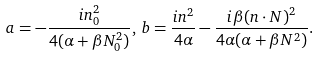<formula> <loc_0><loc_0><loc_500><loc_500>a = - \frac { i n _ { 0 } ^ { 2 } } { 4 ( \alpha + \beta N _ { 0 } ^ { 2 } ) } , \, b = \frac { i { n } ^ { 2 } } { 4 \alpha } - \frac { i \beta ( { n } \cdot { N } ) ^ { 2 } } { 4 \alpha ( \alpha + \beta { N } ^ { 2 } ) } .</formula> 